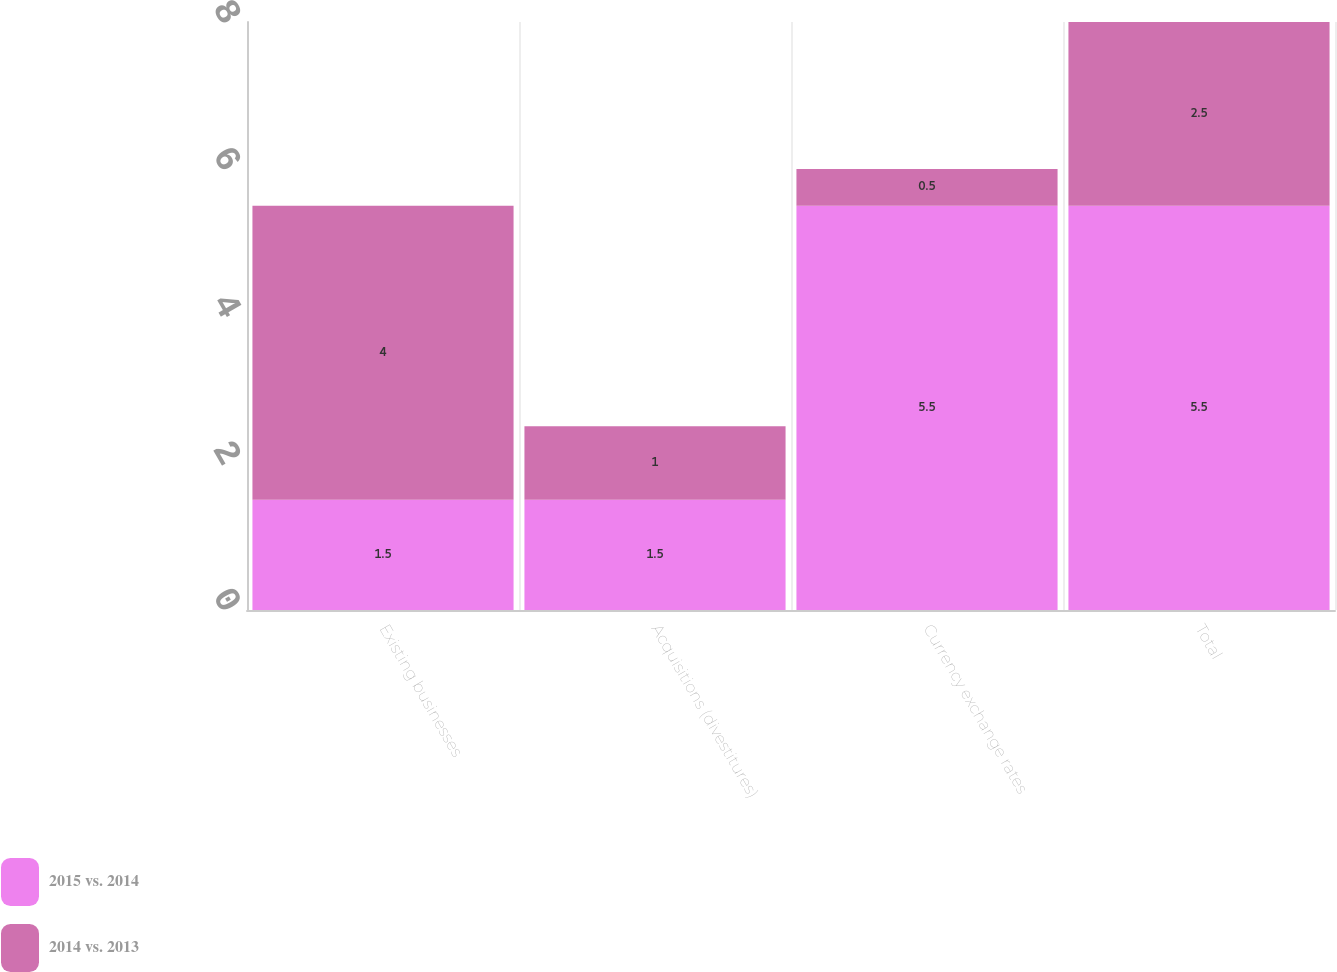Convert chart. <chart><loc_0><loc_0><loc_500><loc_500><stacked_bar_chart><ecel><fcel>Existing businesses<fcel>Acquisitions (divestitures)<fcel>Currency exchange rates<fcel>Total<nl><fcel>2015 vs. 2014<fcel>1.5<fcel>1.5<fcel>5.5<fcel>5.5<nl><fcel>2014 vs. 2013<fcel>4<fcel>1<fcel>0.5<fcel>2.5<nl></chart> 